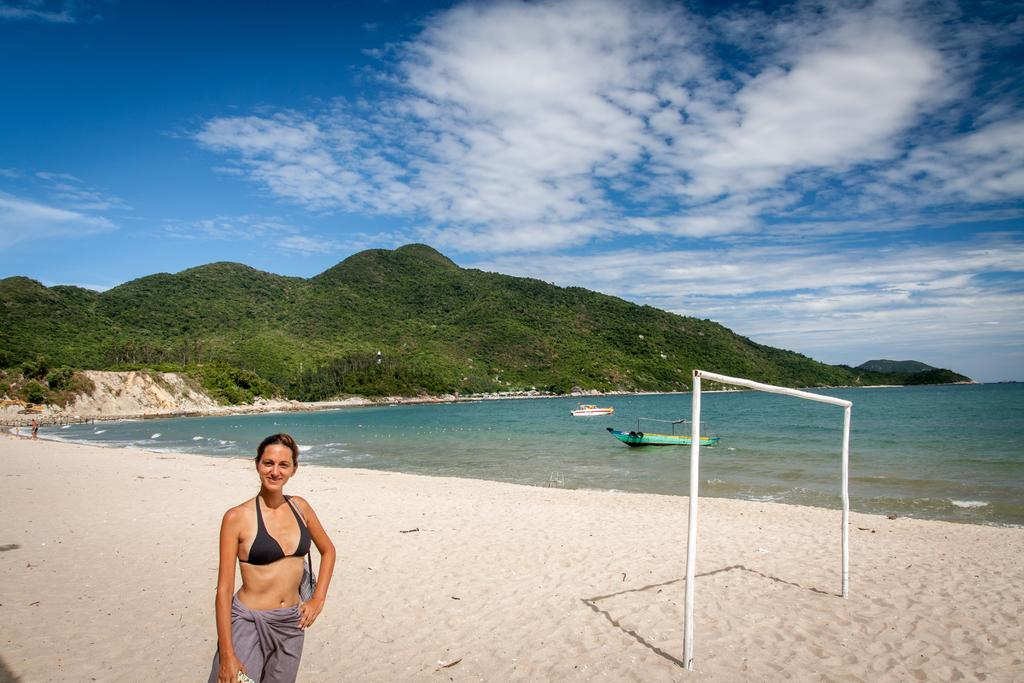Who is present in the image? There is a woman in the image. What is the woman doing in the image? The woman is smiling in the image. Where is the woman standing in the image? The woman is standing on the sand in the image. What can be seen in the background of the image? There are trees, mountains, and the sky visible in the background of the image. What is present on the water in the image? There are boats on the water in the image. What else can be seen in the image? There are poles in the image. What type of furniture is being offered by the woman in the image? There is no furniture present in the image, nor is the woman offering any. 